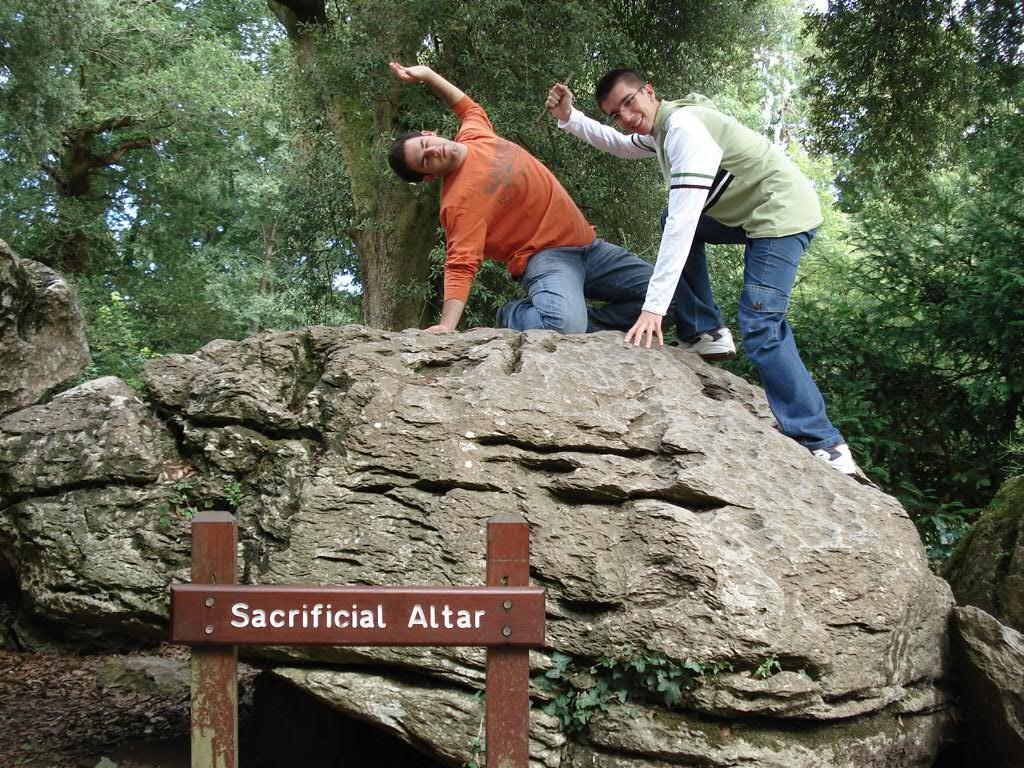How many people are in the image? There are two men in the image. Where are the men located in the image? The men are on a rock in the image. What can be seen on the street sign in the image? There is text on the street sign in the image. What type of vegetation is present in the image? There is a group of trees in the image. What is visible in the background of the image? The sky is visible in the image. What type of government is depicted in the image? There is no depiction of a government in the image; it features two men on a rock, a street sign, trees, and the sky. 